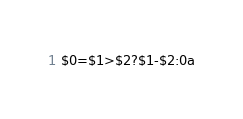<code> <loc_0><loc_0><loc_500><loc_500><_Awk_>$0=$1>$2?$1-$2:0a</code> 